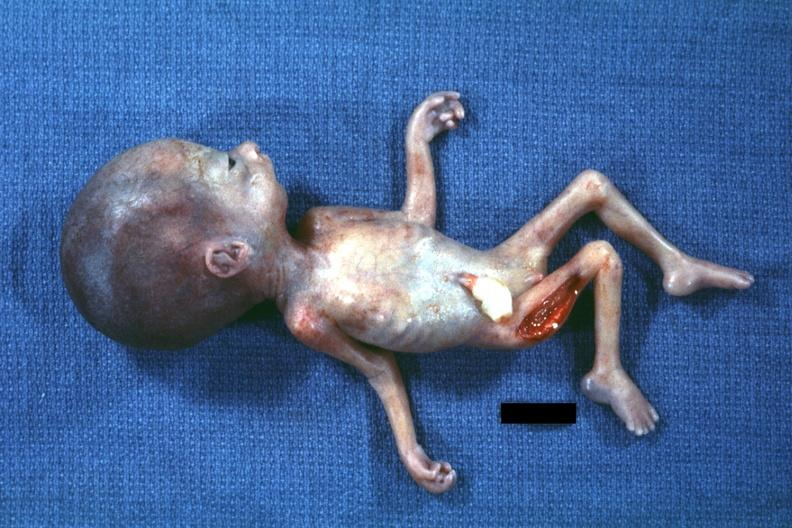does this image show photo of whole body showing head laterally with no chin?
Answer the question using a single word or phrase. Yes 